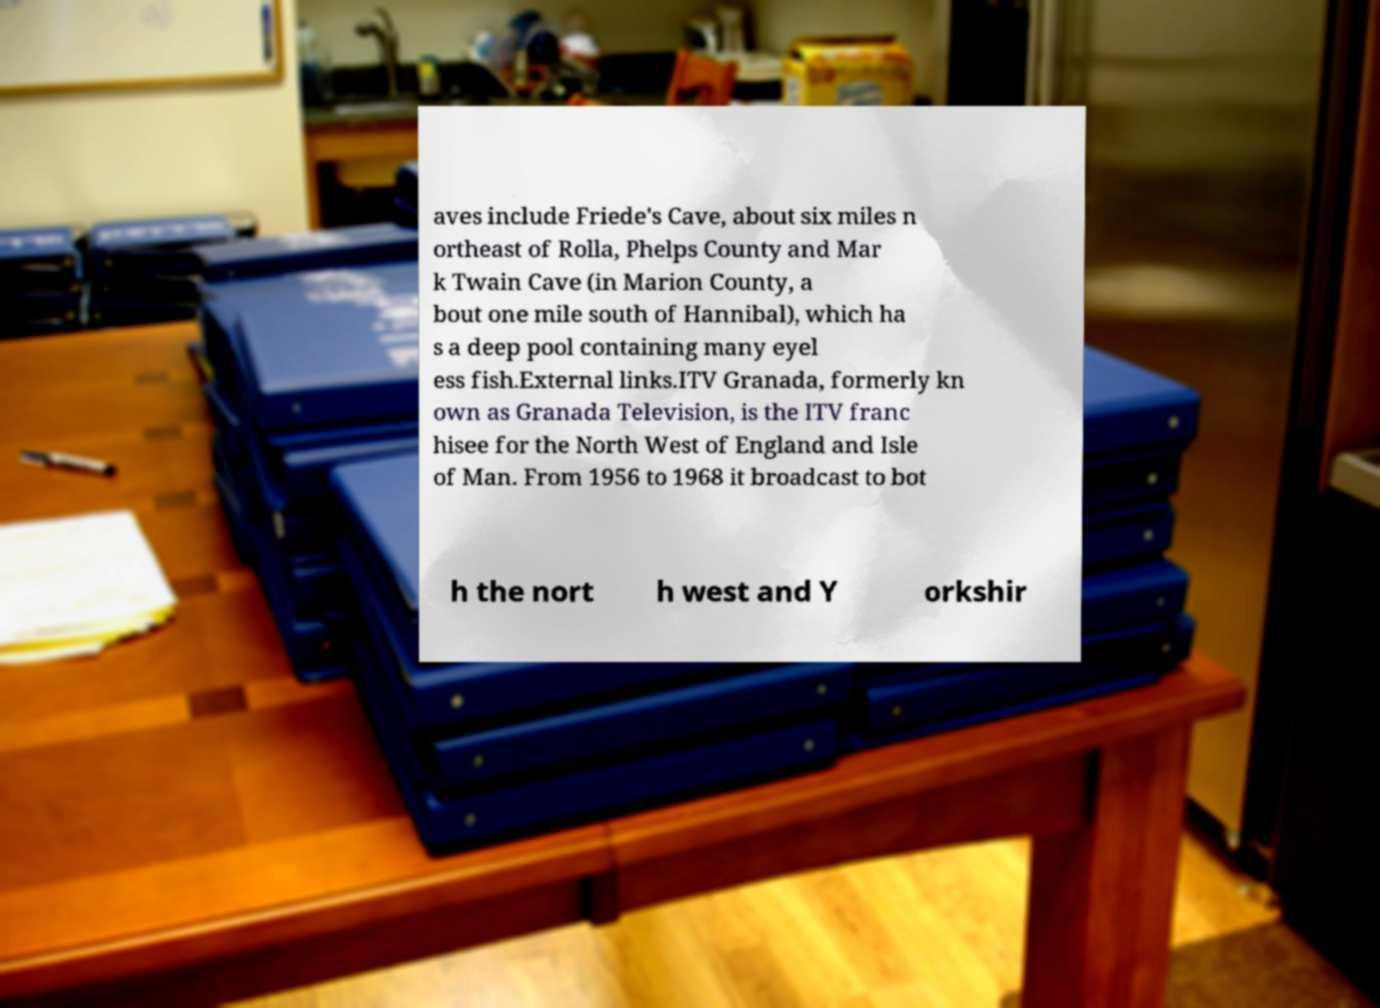I need the written content from this picture converted into text. Can you do that? aves include Friede's Cave, about six miles n ortheast of Rolla, Phelps County and Mar k Twain Cave (in Marion County, a bout one mile south of Hannibal), which ha s a deep pool containing many eyel ess fish.External links.ITV Granada, formerly kn own as Granada Television, is the ITV franc hisee for the North West of England and Isle of Man. From 1956 to 1968 it broadcast to bot h the nort h west and Y orkshir 